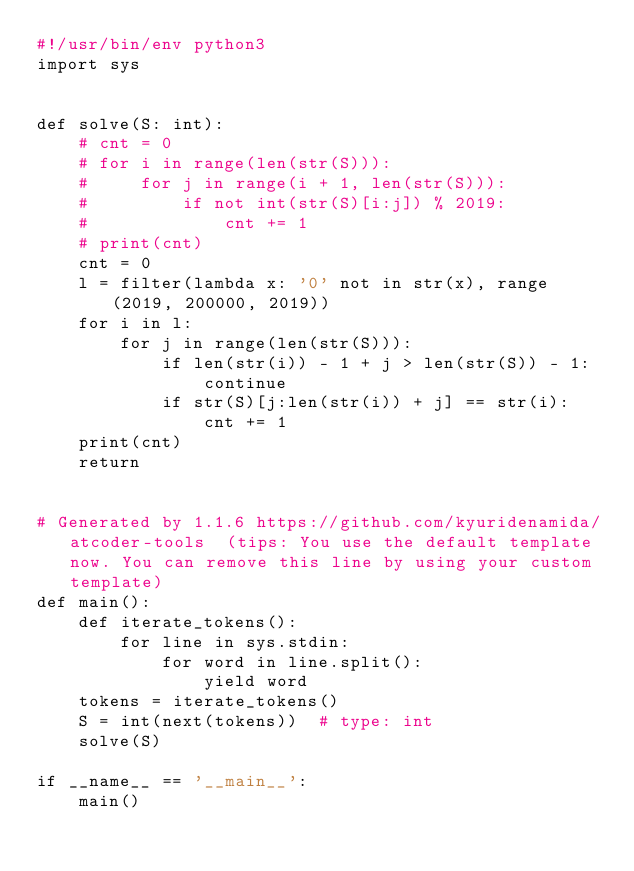<code> <loc_0><loc_0><loc_500><loc_500><_Python_>#!/usr/bin/env python3
import sys


def solve(S: int):
    # cnt = 0
    # for i in range(len(str(S))):
    #     for j in range(i + 1, len(str(S))):
    #         if not int(str(S)[i:j]) % 2019:
    #             cnt += 1
    # print(cnt)
    cnt = 0
    l = filter(lambda x: '0' not in str(x), range(2019, 200000, 2019))
    for i in l:
        for j in range(len(str(S))):
            if len(str(i)) - 1 + j > len(str(S)) - 1:
                continue
            if str(S)[j:len(str(i)) + j] == str(i):
                cnt += 1
    print(cnt)
    return


# Generated by 1.1.6 https://github.com/kyuridenamida/atcoder-tools  (tips: You use the default template now. You can remove this line by using your custom template)
def main():
    def iterate_tokens():
        for line in sys.stdin:
            for word in line.split():
                yield word
    tokens = iterate_tokens()
    S = int(next(tokens))  # type: int
    solve(S)

if __name__ == '__main__':
    main()
</code> 